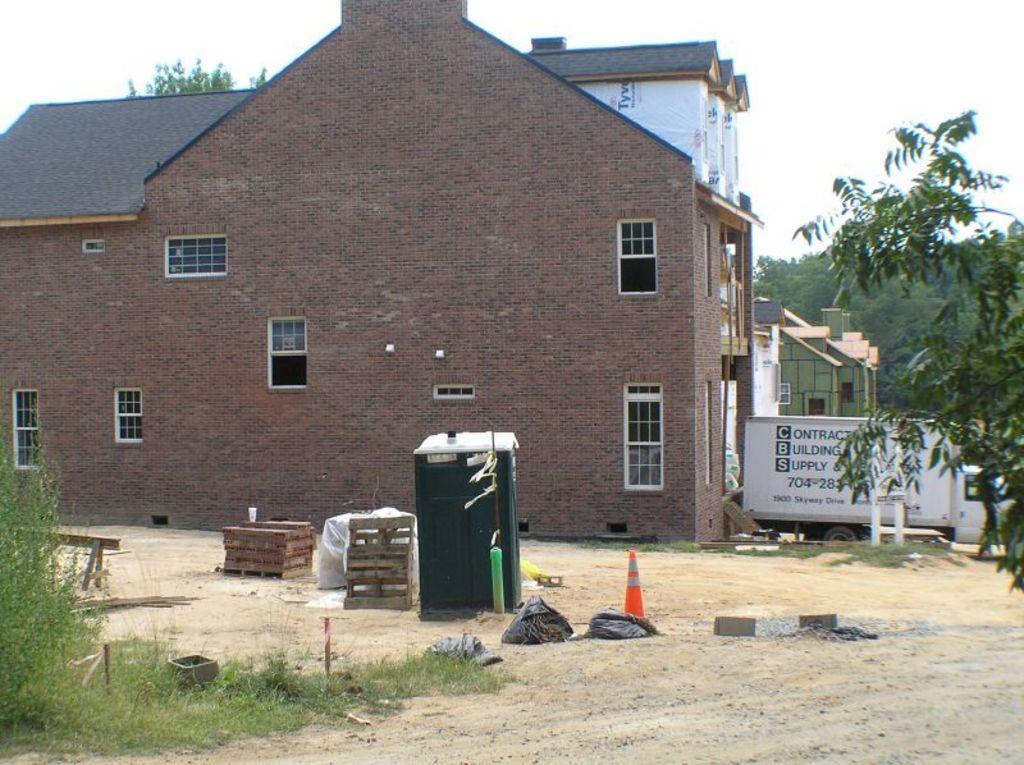In one or two sentences, can you explain what this image depicts? In this image we can see some houses, some objects attached to the wall, one vehicle parked in front of the house, some text on the vehicle, one name board with poles, some text on the house wall, one safety pole, two wooden objects, some stones and some objects on the ground. There are some trees, bushes, plants and grass on the ground. At the top there is the sky. 